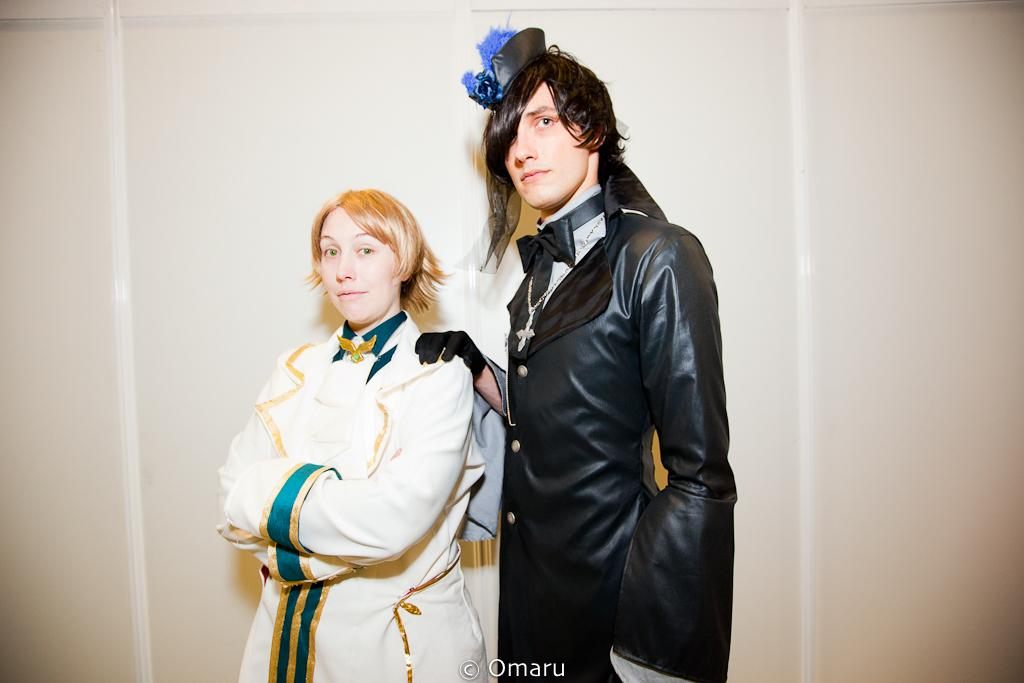Where was the image taken? The image was taken indoors. What can be seen in the background of the image? There is a wall in the background of the image. Who are the people in the image? A man and a woman are standing in the middle of the image. What are the man and the woman wearing? The man and the woman are wearing beautiful costumes. Is there a beggar asking for money in the image? No, there is no beggar present in the image. What type of flesh can be seen in the image? There is no flesh visible in the image; it features a man and a woman wearing costumes. 